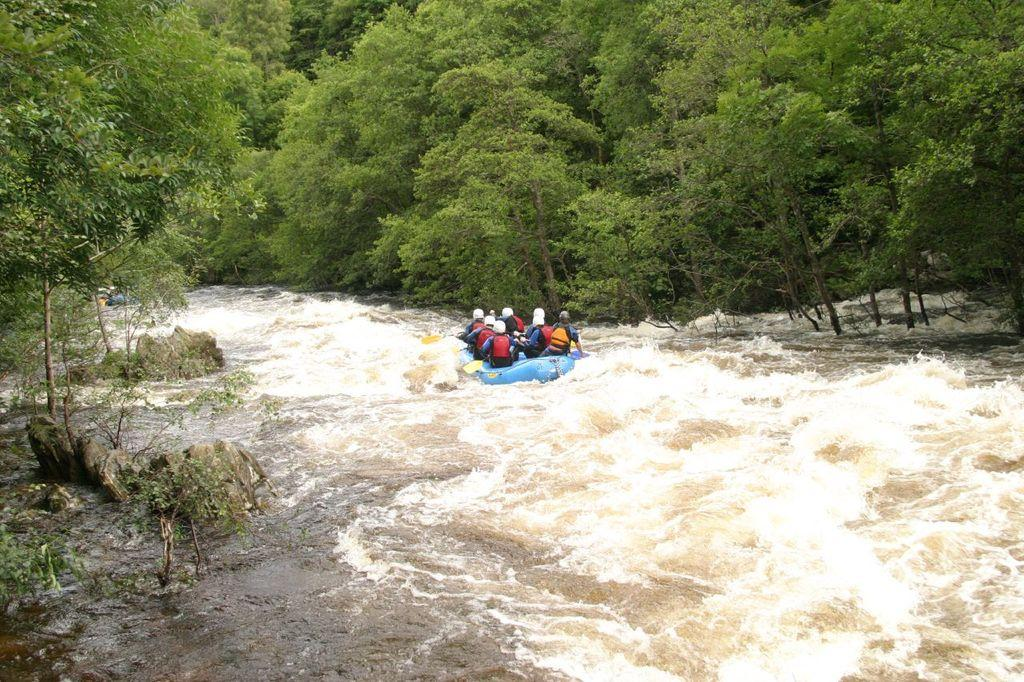What are the persons in the image doing? The persons in the image are sailing in a boat. What can be seen at the bottom of the image? There is water visible at the bottom of the image. What is present on the left side of the image? There are trees on the left side of the image. What is present on the right side of the image? There are trees on the right side of the image. Can you tell me how many cherries are being sorted by the persons in the image? There are no cherries or sorting activity present in the image; the persons are sailing in a boat. Is there a basketball court visible in the image? There is no basketball court present in the image; the image features persons sailing in a boat surrounded by water and trees. 